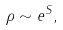<formula> <loc_0><loc_0><loc_500><loc_500>\rho \sim e ^ { S } ,</formula> 